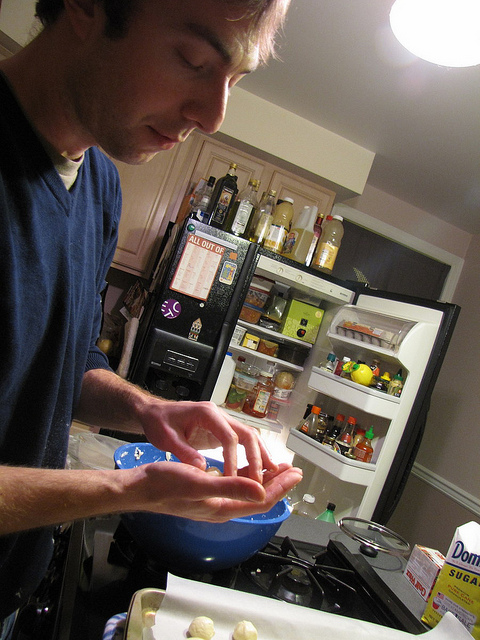Please transcribe the text information in this image. Dom SUGA All OF OUT 